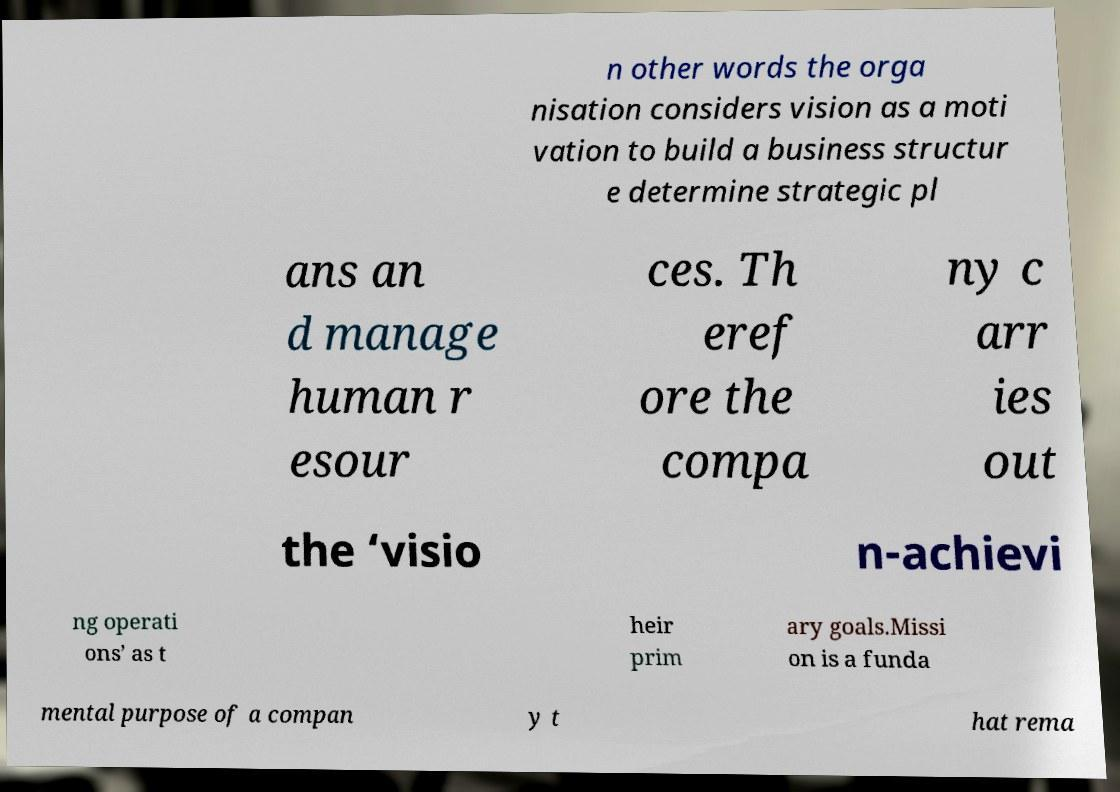For documentation purposes, I need the text within this image transcribed. Could you provide that? n other words the orga nisation considers vision as a moti vation to build a business structur e determine strategic pl ans an d manage human r esour ces. Th eref ore the compa ny c arr ies out the ‘visio n-achievi ng operati ons’ as t heir prim ary goals.Missi on is a funda mental purpose of a compan y t hat rema 